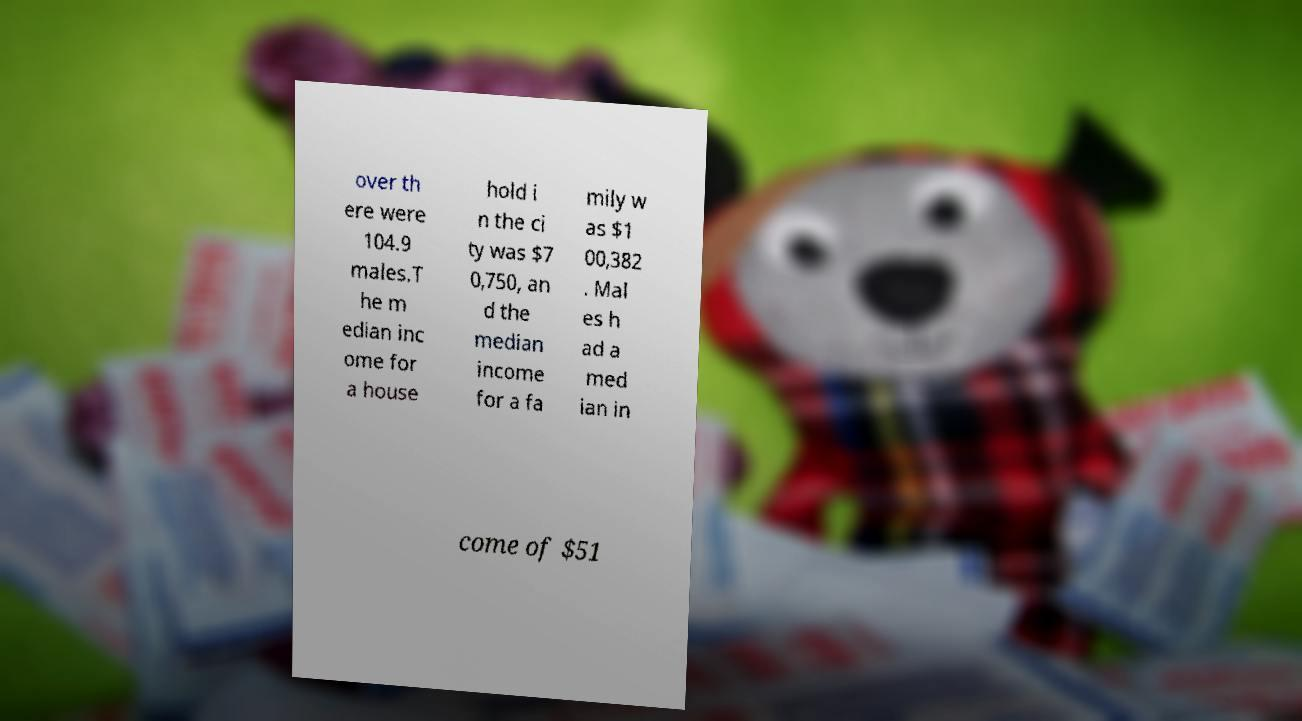Could you extract and type out the text from this image? over th ere were 104.9 males.T he m edian inc ome for a house hold i n the ci ty was $7 0,750, an d the median income for a fa mily w as $1 00,382 . Mal es h ad a med ian in come of $51 